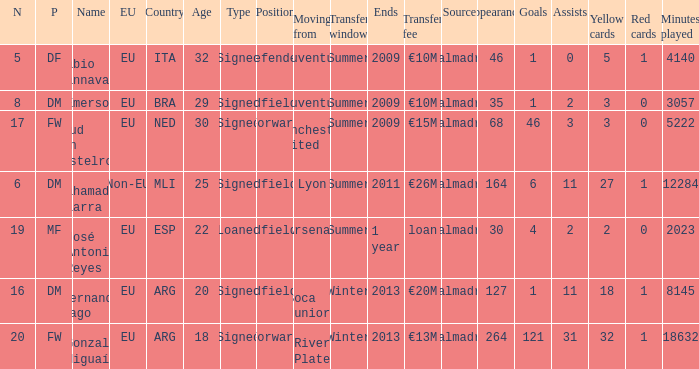How many numbers are ending in 1 year? 1.0. 